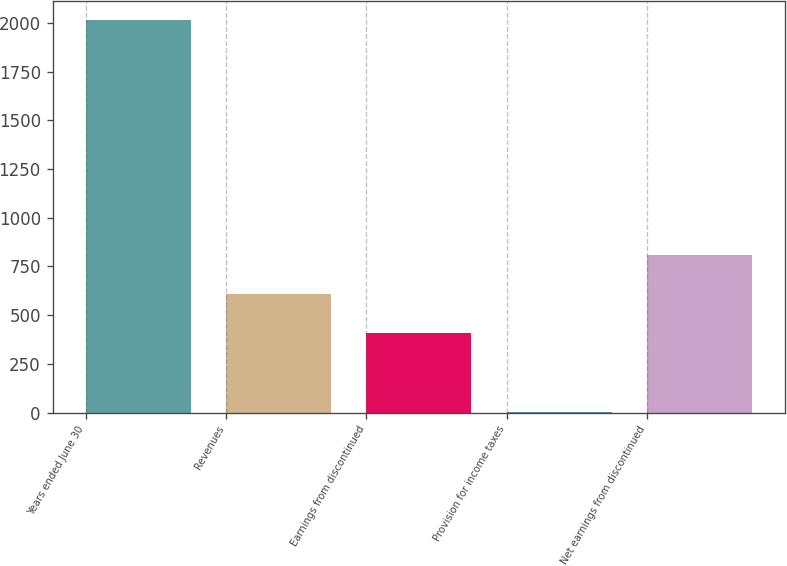<chart> <loc_0><loc_0><loc_500><loc_500><bar_chart><fcel>Years ended June 30<fcel>Revenues<fcel>Earnings from discontinued<fcel>Provision for income taxes<fcel>Net earnings from discontinued<nl><fcel>2013<fcel>607.54<fcel>406.76<fcel>5.2<fcel>808.32<nl></chart> 